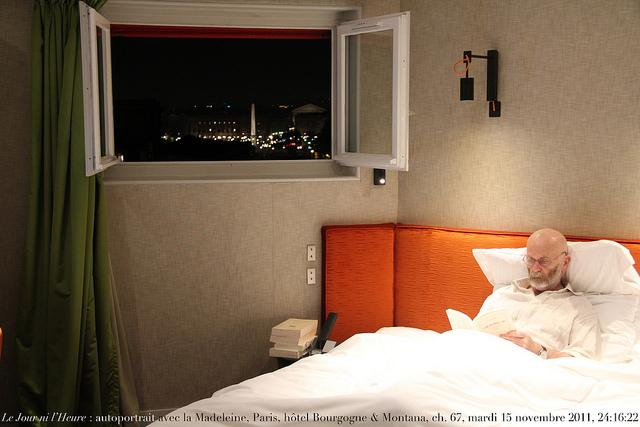Why does he need the light to be on? Please explain your reasoning. reading. He is using the light for reading 